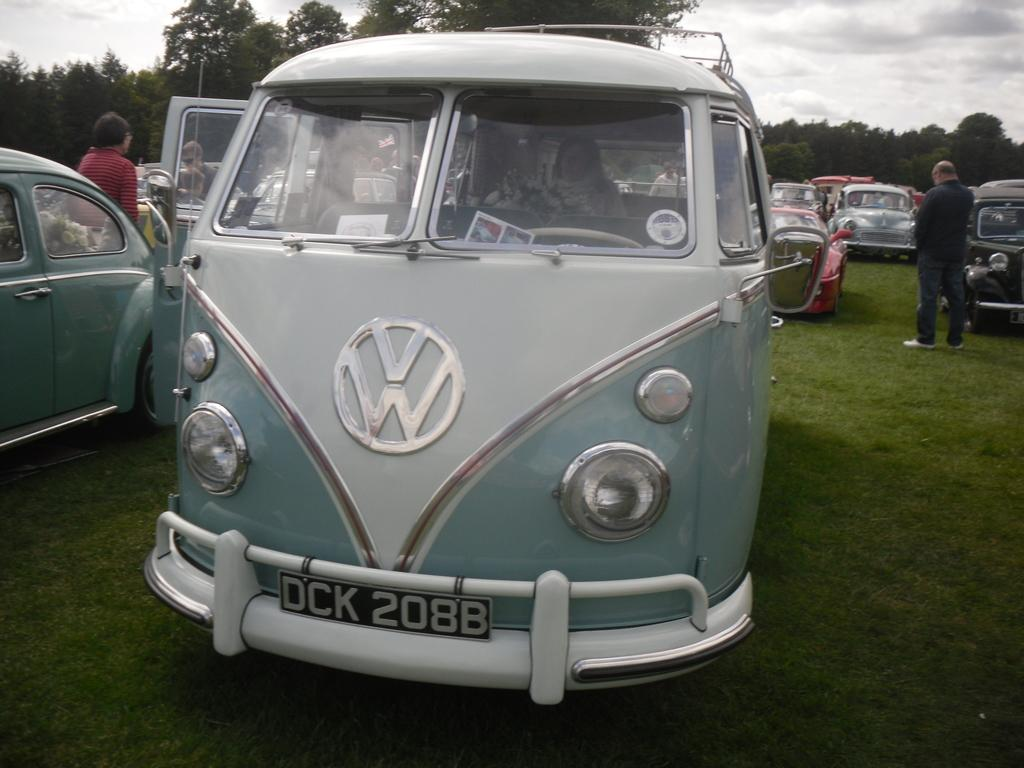<image>
Give a short and clear explanation of the subsequent image. An old style van which has the letters DCK on the number plate. 